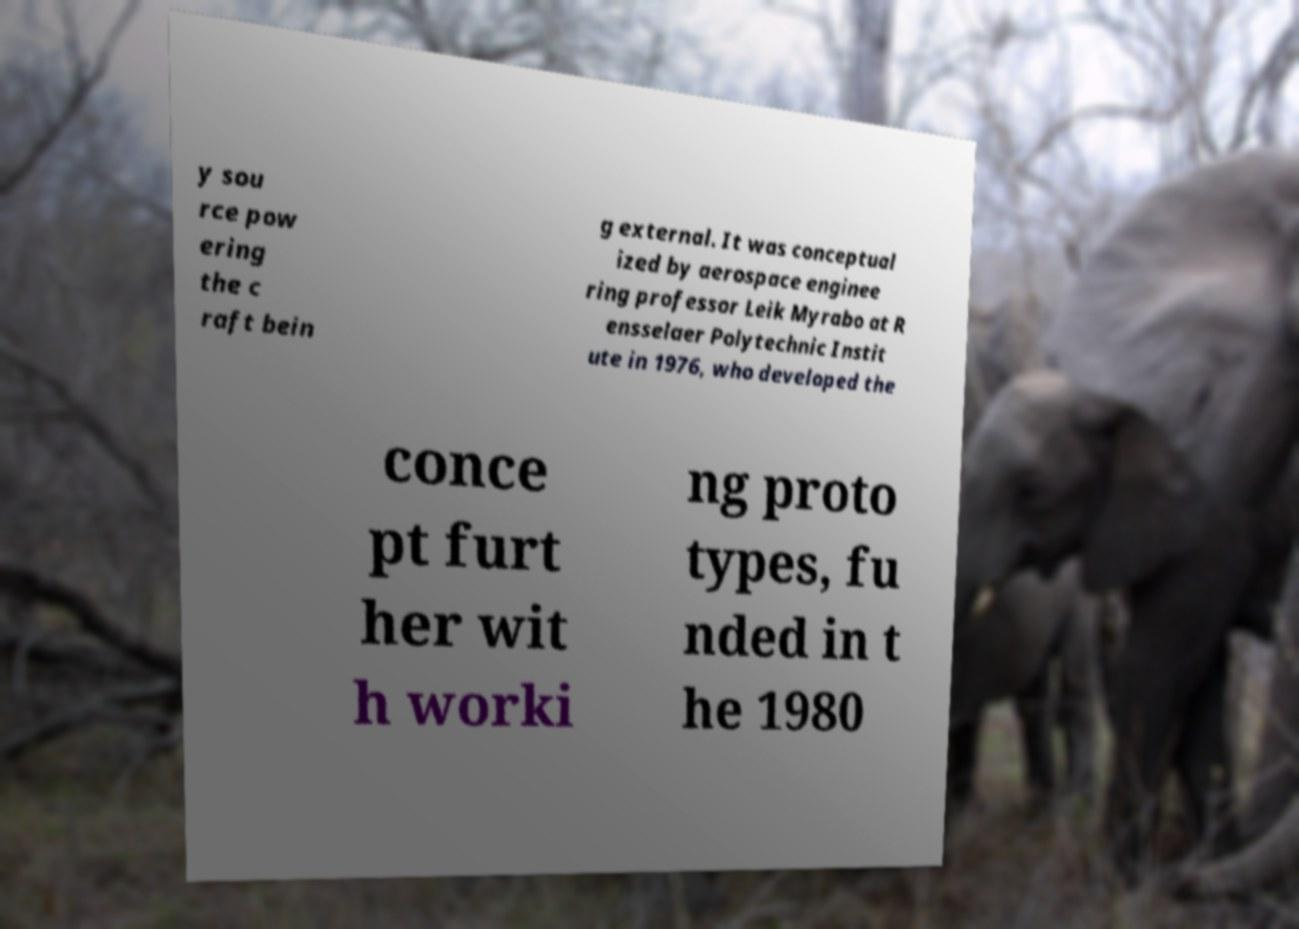What messages or text are displayed in this image? I need them in a readable, typed format. y sou rce pow ering the c raft bein g external. It was conceptual ized by aerospace enginee ring professor Leik Myrabo at R ensselaer Polytechnic Instit ute in 1976, who developed the conce pt furt her wit h worki ng proto types, fu nded in t he 1980 